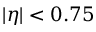<formula> <loc_0><loc_0><loc_500><loc_500>| \eta | < 0 . 7 5</formula> 